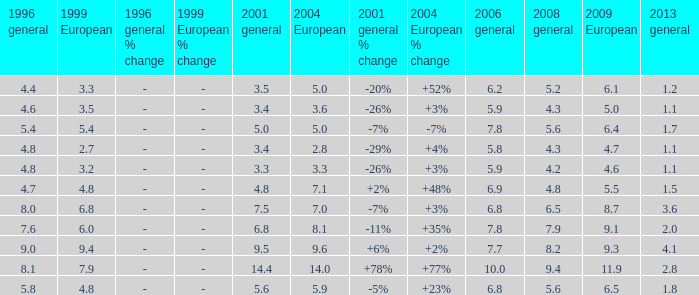What is the average value for general 2001 with more than 4.8 in 1999 European, 7.7 in 2006 general, and more than 9 in 1996 general? None. 